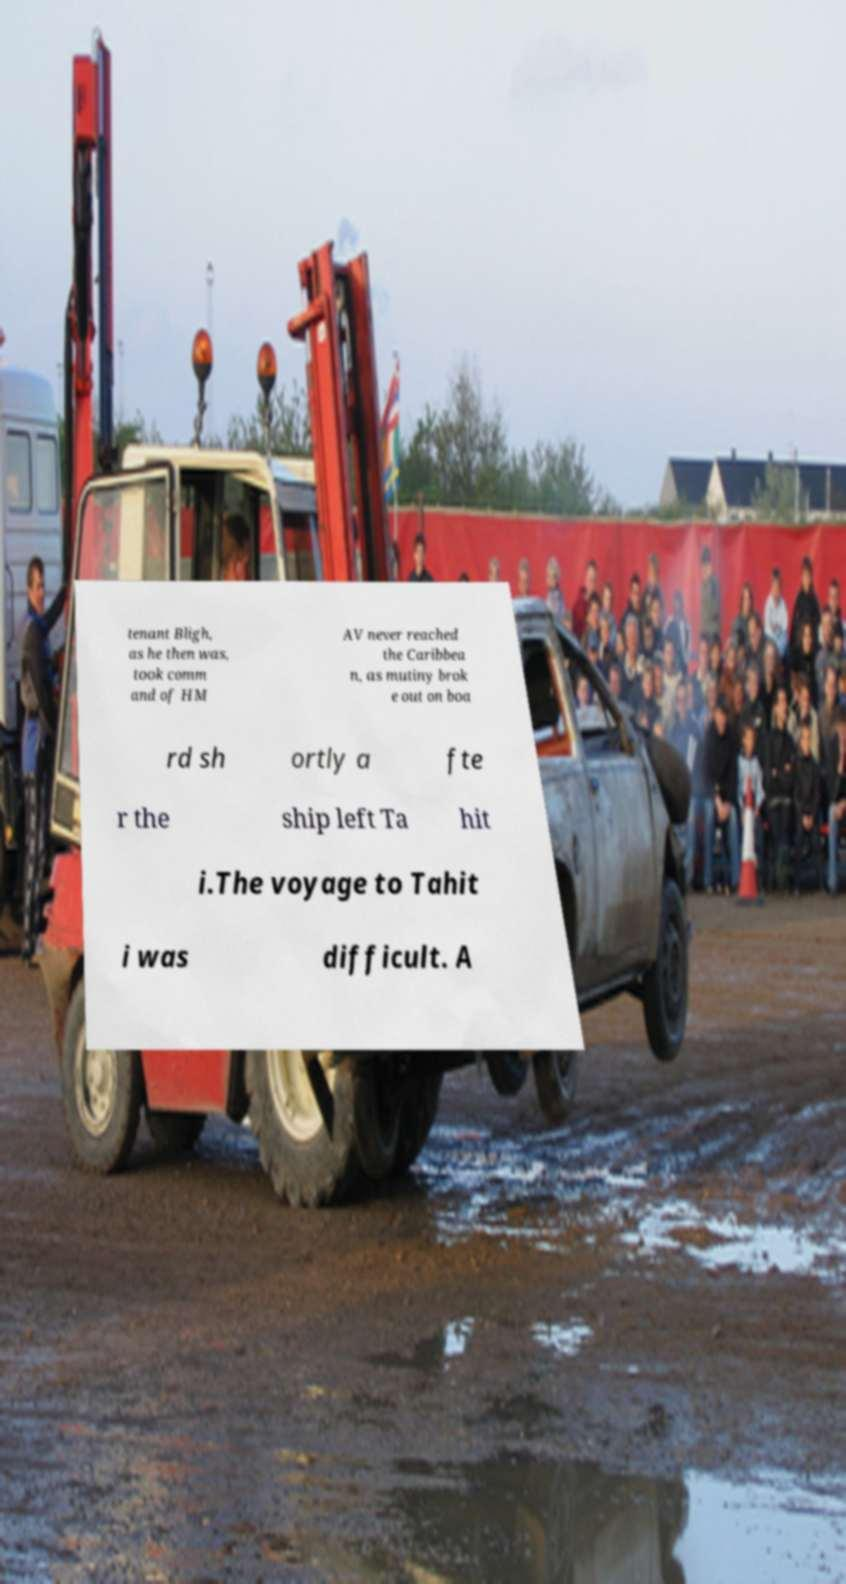Could you extract and type out the text from this image? tenant Bligh, as he then was, took comm and of HM AV never reached the Caribbea n, as mutiny brok e out on boa rd sh ortly a fte r the ship left Ta hit i.The voyage to Tahit i was difficult. A 